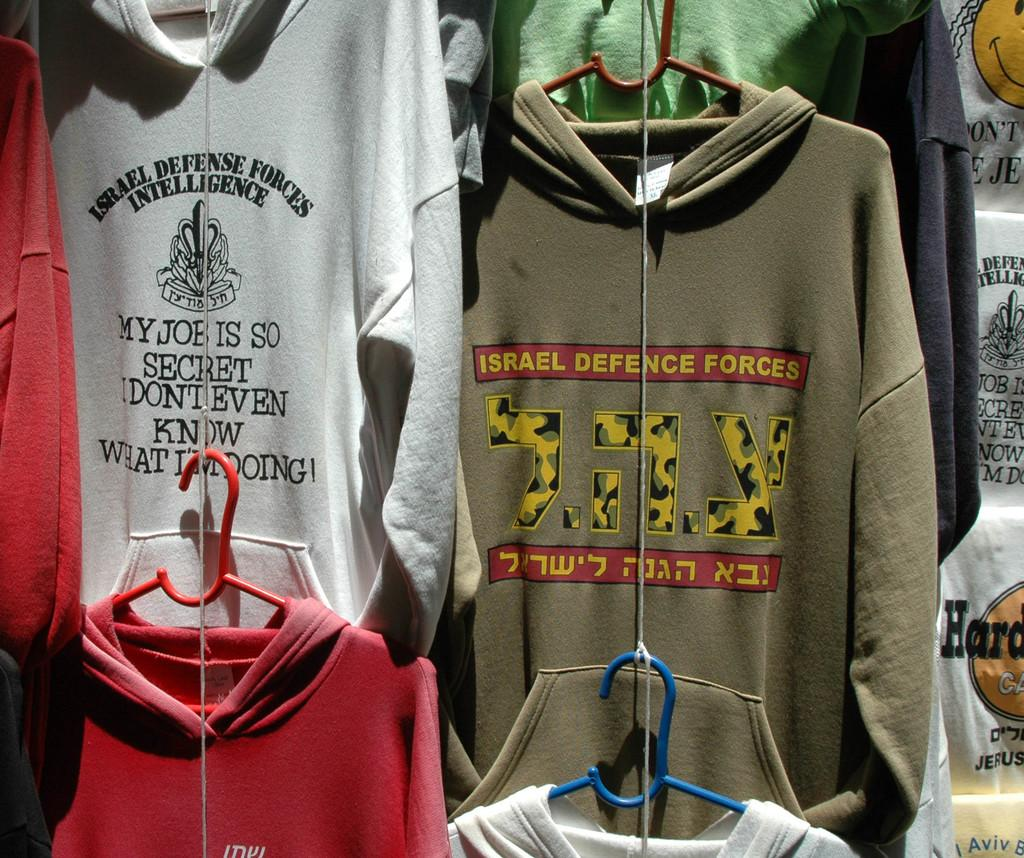What type of clothing is featured in the image? There are hoodies in the image. How are the hoodies presented in the image? The hoodies are on display. What type of dock can be seen in the image? There is no dock present in the image; it features hoodies on display. What emotion is being expressed by the hoodies in the image? Hoodies are inanimate objects and cannot express emotions like love. 